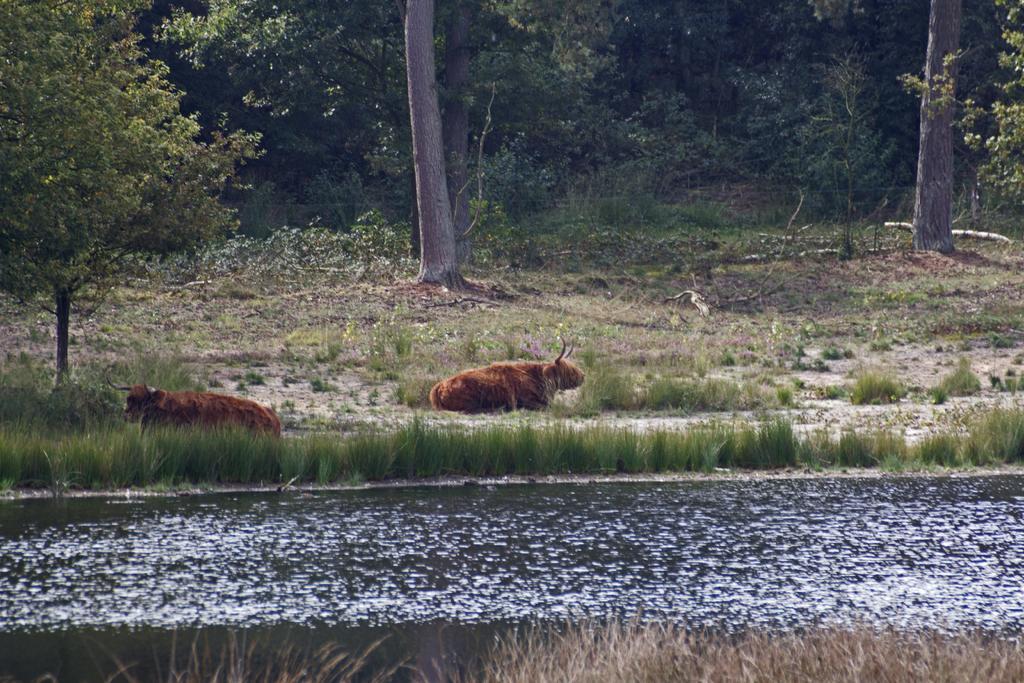Can you describe this image briefly? At the bottom of the image there is grass. Behind the grass there is water. Behind the water on the ground there is grass and also there are two animals. In the background there are trees. 